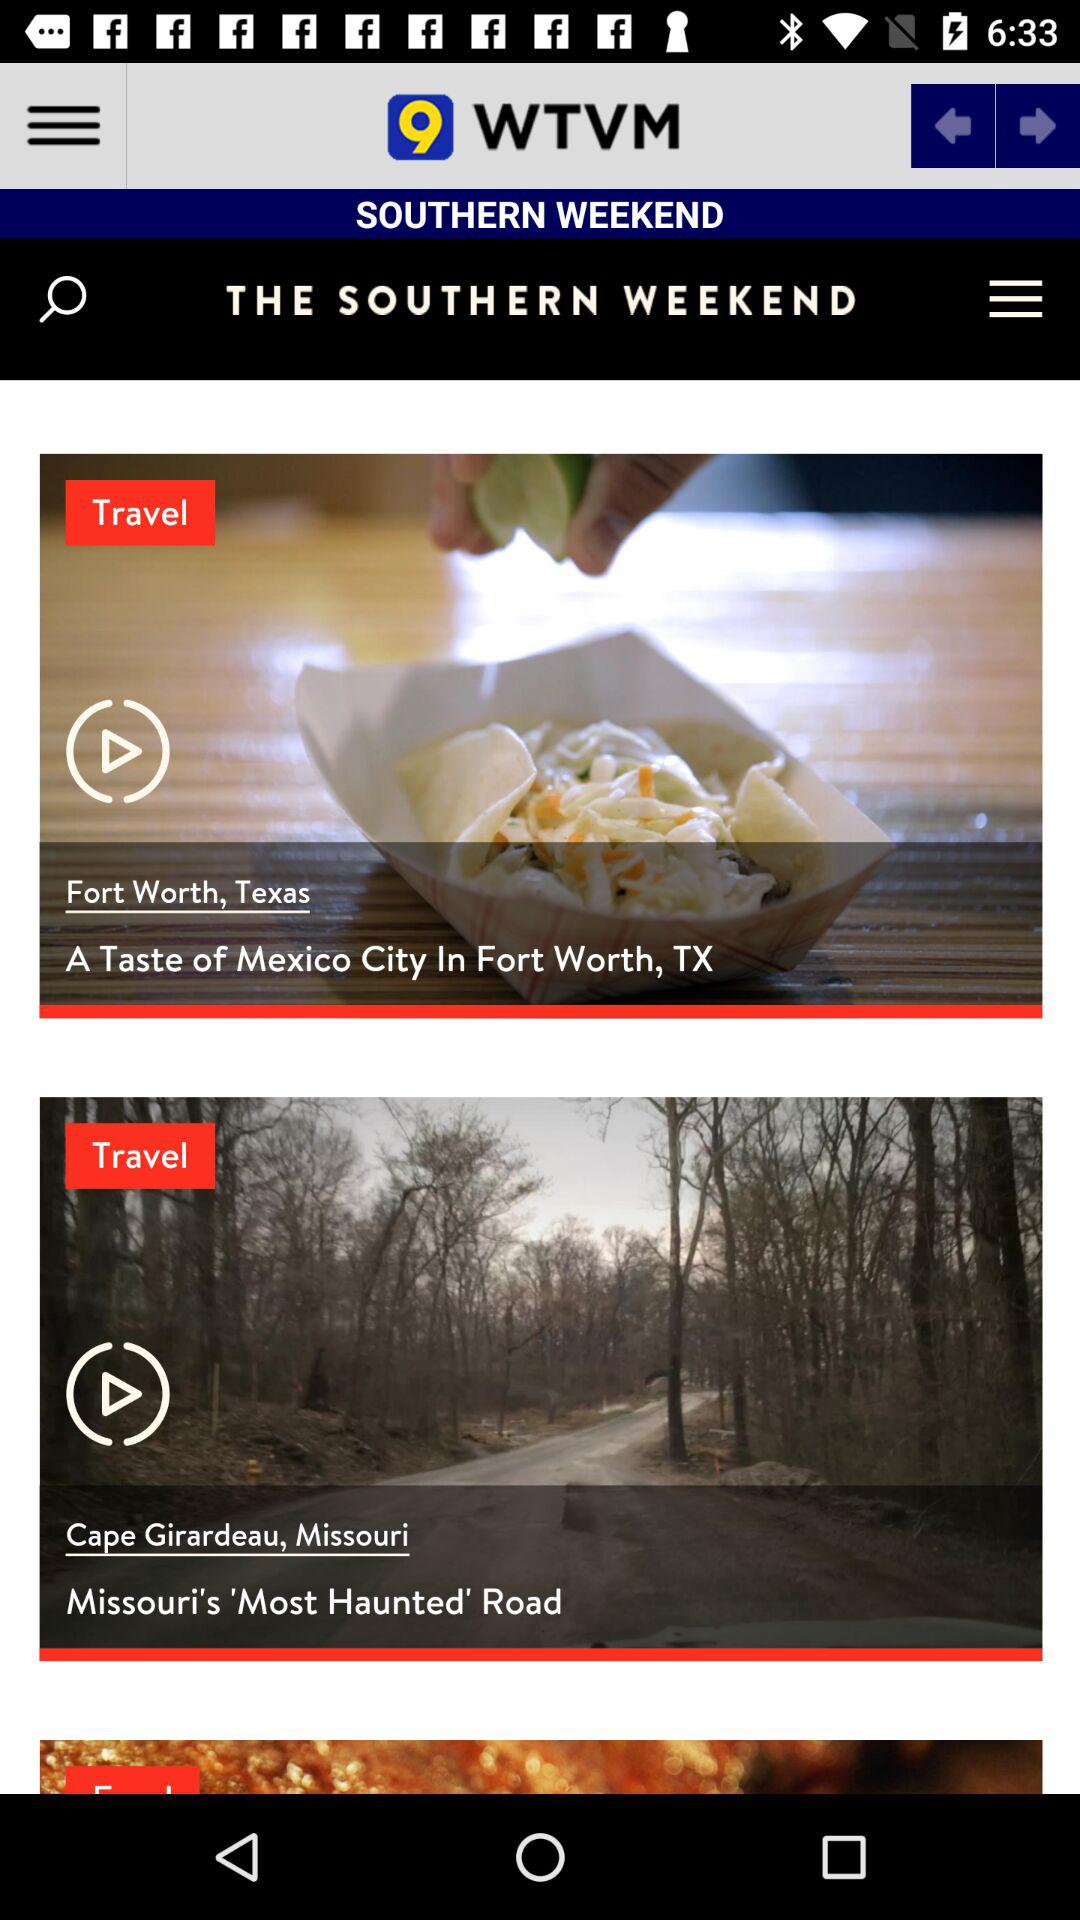Where is Missouri's Most Haunted Road located? Missouri's Most Haunted Road is located in Cape Girardeau, Missouri. 